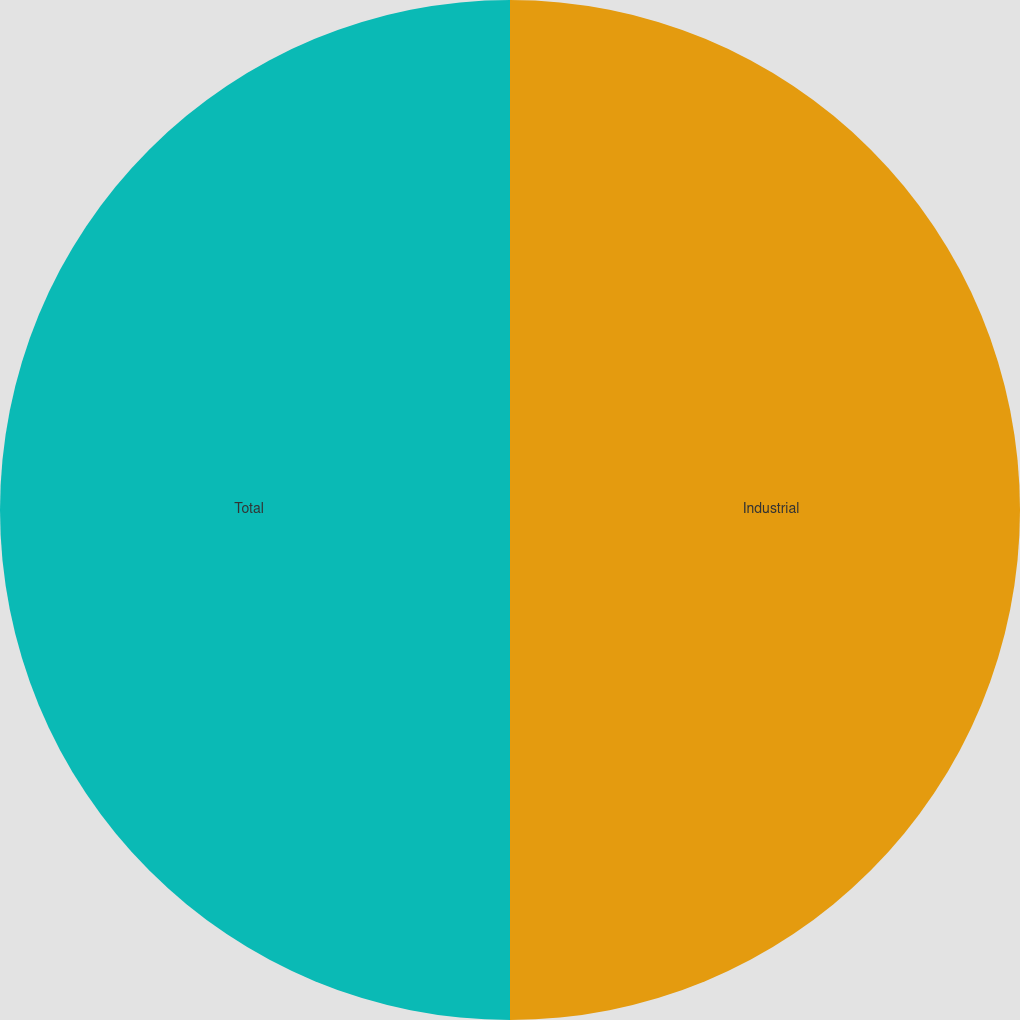Convert chart. <chart><loc_0><loc_0><loc_500><loc_500><pie_chart><fcel>Industrial<fcel>Total<nl><fcel>50.0%<fcel>50.0%<nl></chart> 